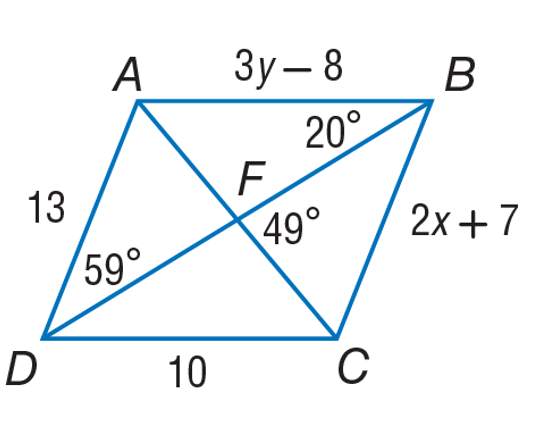Use parallelogram ABCD to find y. To find the value of y, we look at the parallelogram ABCD where side AB is labelled as 3y - 8 and side CD as 2x + 7. Since opposite sides of a parallelogram are equal, we have that 3y - 8 = 10. Solving for y gives us y = 6. Therefore, the correct choice for the value of y is B: 6. 